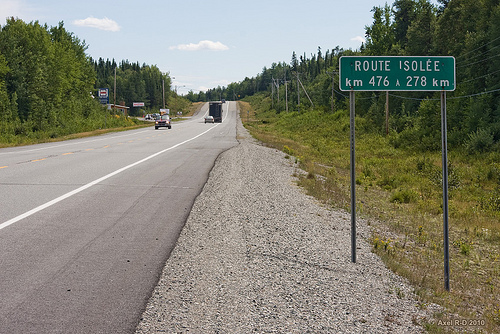<image>
Is there a road under the sky? Yes. The road is positioned underneath the sky, with the sky above it in the vertical space. 